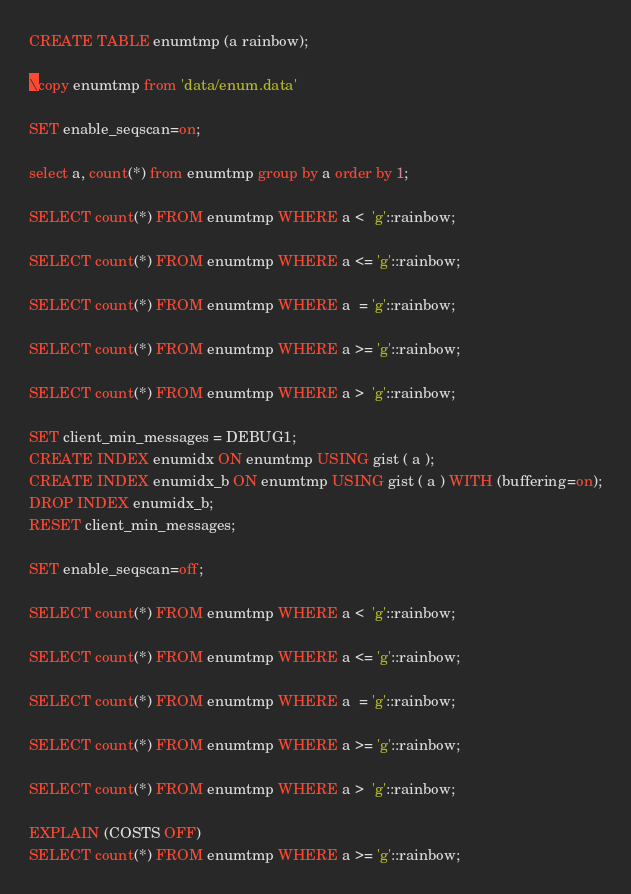<code> <loc_0><loc_0><loc_500><loc_500><_SQL_>
CREATE TABLE enumtmp (a rainbow);

\copy enumtmp from 'data/enum.data'

SET enable_seqscan=on;

select a, count(*) from enumtmp group by a order by 1;

SELECT count(*) FROM enumtmp WHERE a <  'g'::rainbow;

SELECT count(*) FROM enumtmp WHERE a <= 'g'::rainbow;

SELECT count(*) FROM enumtmp WHERE a  = 'g'::rainbow;

SELECT count(*) FROM enumtmp WHERE a >= 'g'::rainbow;

SELECT count(*) FROM enumtmp WHERE a >  'g'::rainbow;

SET client_min_messages = DEBUG1;
CREATE INDEX enumidx ON enumtmp USING gist ( a );
CREATE INDEX enumidx_b ON enumtmp USING gist ( a ) WITH (buffering=on);
DROP INDEX enumidx_b;
RESET client_min_messages;

SET enable_seqscan=off;

SELECT count(*) FROM enumtmp WHERE a <  'g'::rainbow;

SELECT count(*) FROM enumtmp WHERE a <= 'g'::rainbow;

SELECT count(*) FROM enumtmp WHERE a  = 'g'::rainbow;

SELECT count(*) FROM enumtmp WHERE a >= 'g'::rainbow;

SELECT count(*) FROM enumtmp WHERE a >  'g'::rainbow;

EXPLAIN (COSTS OFF)
SELECT count(*) FROM enumtmp WHERE a >= 'g'::rainbow;
</code> 